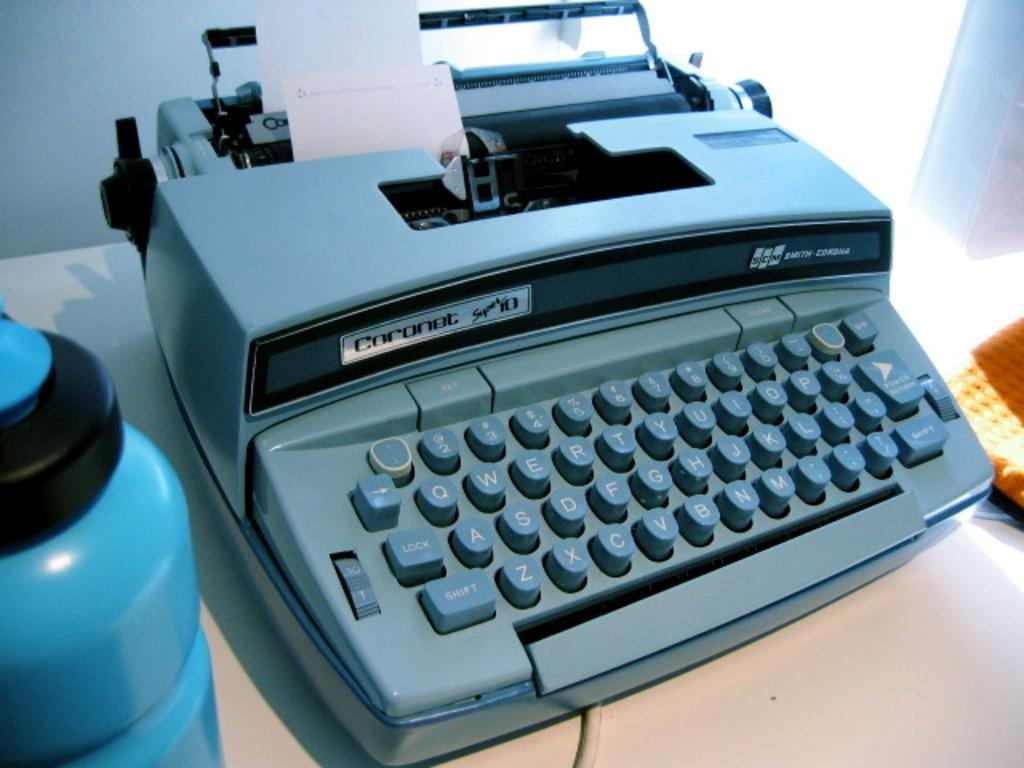<image>
Create a compact narrative representing the image presented. A blue Coronet typewriter loaded with a small strip of paper is on a flat surface. 